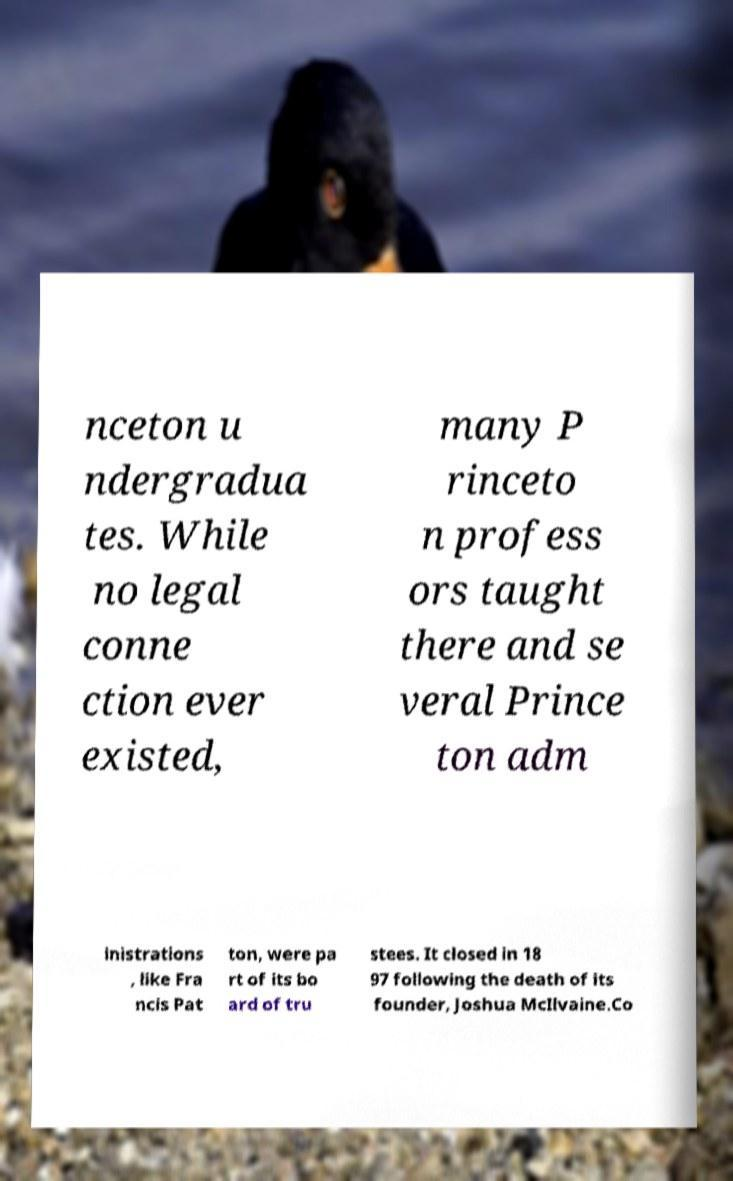Please identify and transcribe the text found in this image. nceton u ndergradua tes. While no legal conne ction ever existed, many P rinceto n profess ors taught there and se veral Prince ton adm inistrations , like Fra ncis Pat ton, were pa rt of its bo ard of tru stees. It closed in 18 97 following the death of its founder, Joshua McIlvaine.Co 